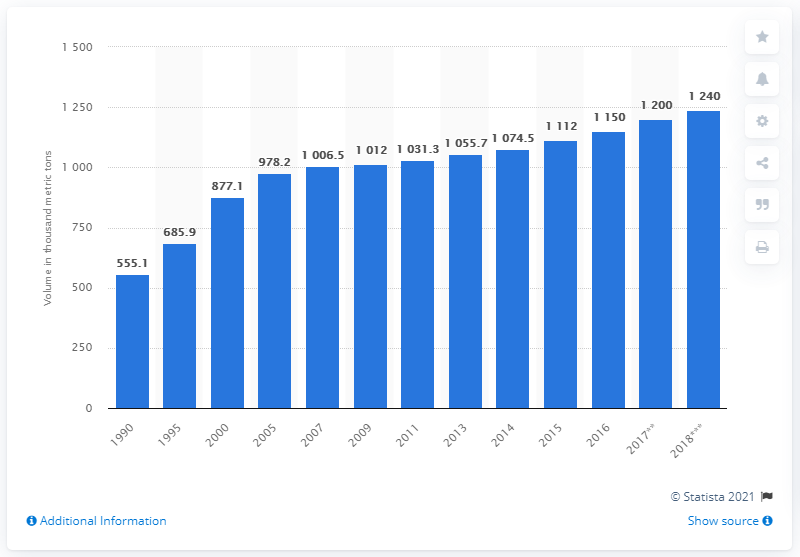Highlight a few significant elements in this photo. In the previous year, the production of broiler meat in Canada was approximately 1112 metric tons. In 2016, a total of 1,150 metric tons of broiler meat was produced in Canada. 